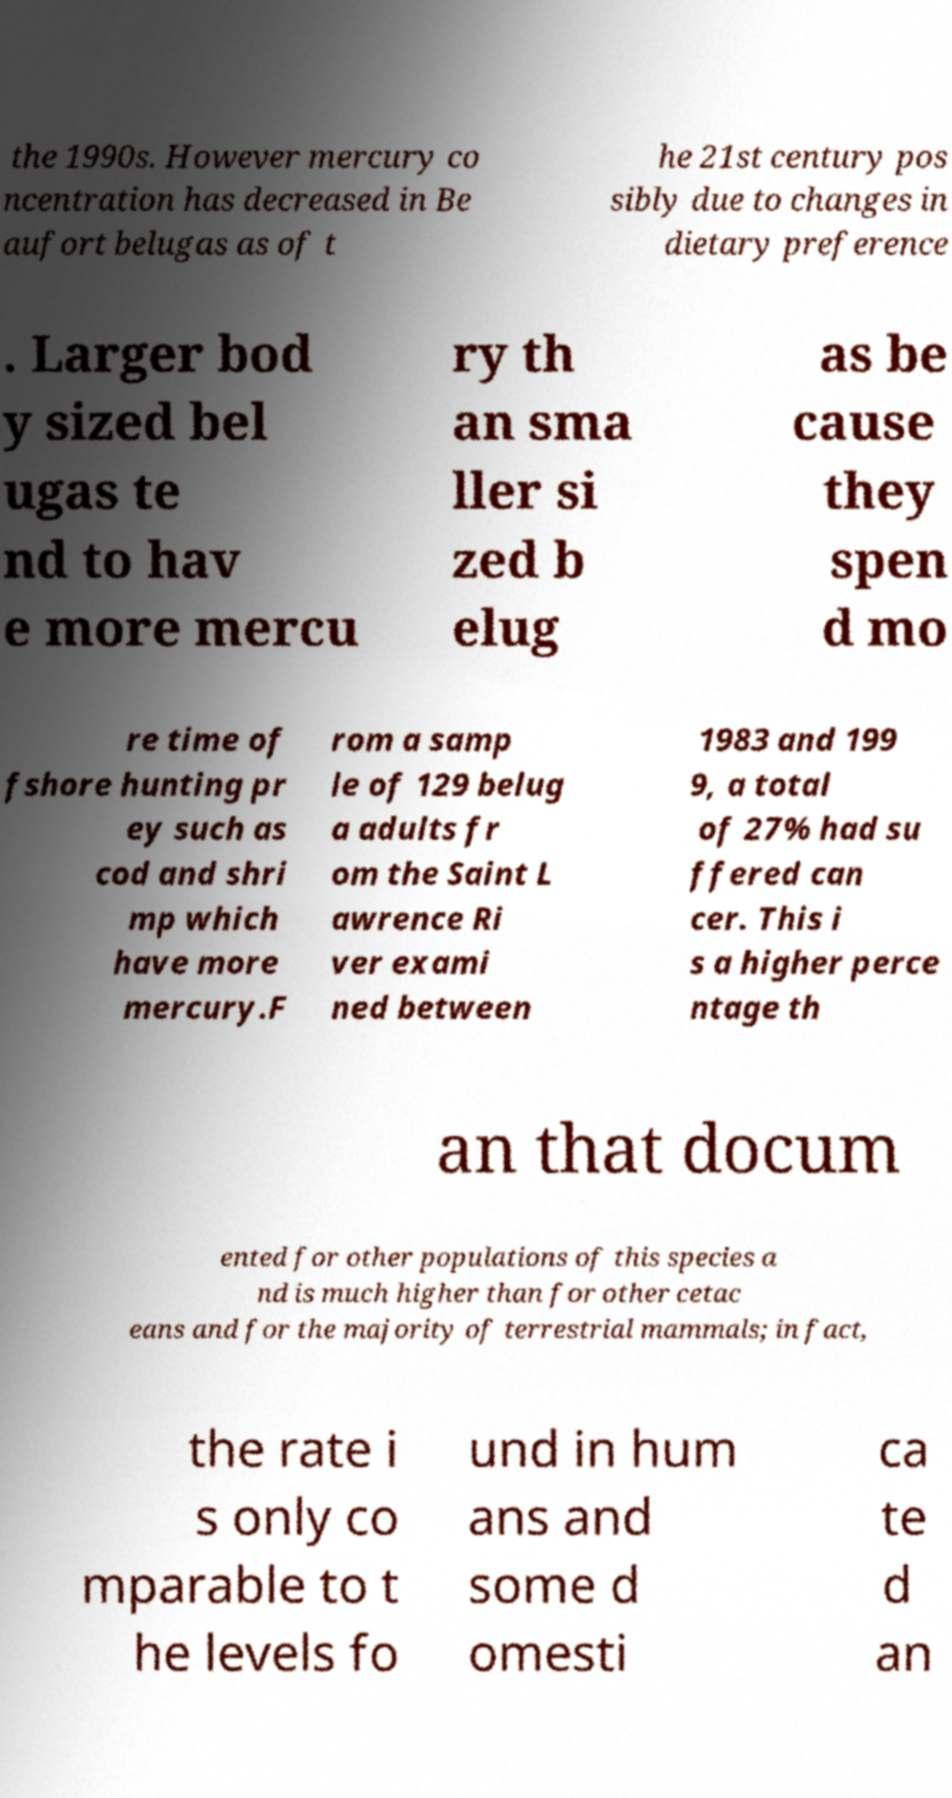For documentation purposes, I need the text within this image transcribed. Could you provide that? the 1990s. However mercury co ncentration has decreased in Be aufort belugas as of t he 21st century pos sibly due to changes in dietary preference . Larger bod y sized bel ugas te nd to hav e more mercu ry th an sma ller si zed b elug as be cause they spen d mo re time of fshore hunting pr ey such as cod and shri mp which have more mercury.F rom a samp le of 129 belug a adults fr om the Saint L awrence Ri ver exami ned between 1983 and 199 9, a total of 27% had su ffered can cer. This i s a higher perce ntage th an that docum ented for other populations of this species a nd is much higher than for other cetac eans and for the majority of terrestrial mammals; in fact, the rate i s only co mparable to t he levels fo und in hum ans and some d omesti ca te d an 